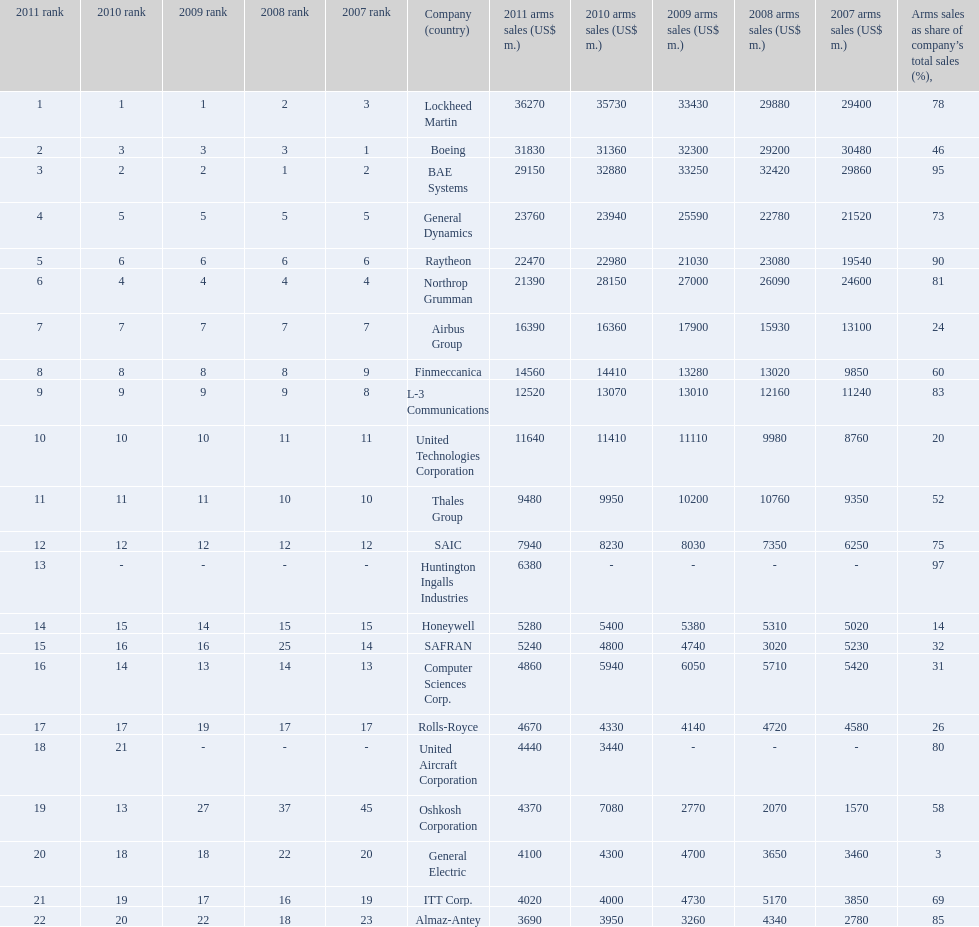Parse the full table. {'header': ['2011 rank', '2010 rank', '2009 rank', '2008 rank', '2007 rank', 'Company (country)', '2011 arms sales (US$ m.)', '2010 arms sales (US$ m.)', '2009 arms sales (US$ m.)', '2008 arms sales (US$ m.)', '2007 arms sales (US$ m.)', 'Arms sales as share of company’s total sales (%),'], 'rows': [['1', '1', '1', '2', '3', 'Lockheed Martin', '36270', '35730', '33430', '29880', '29400', '78'], ['2', '3', '3', '3', '1', 'Boeing', '31830', '31360', '32300', '29200', '30480', '46'], ['3', '2', '2', '1', '2', 'BAE Systems', '29150', '32880', '33250', '32420', '29860', '95'], ['4', '5', '5', '5', '5', 'General Dynamics', '23760', '23940', '25590', '22780', '21520', '73'], ['5', '6', '6', '6', '6', 'Raytheon', '22470', '22980', '21030', '23080', '19540', '90'], ['6', '4', '4', '4', '4', 'Northrop Grumman', '21390', '28150', '27000', '26090', '24600', '81'], ['7', '7', '7', '7', '7', 'Airbus Group', '16390', '16360', '17900', '15930', '13100', '24'], ['8', '8', '8', '8', '9', 'Finmeccanica', '14560', '14410', '13280', '13020', '9850', '60'], ['9', '9', '9', '9', '8', 'L-3 Communications', '12520', '13070', '13010', '12160', '11240', '83'], ['10', '10', '10', '11', '11', 'United Technologies Corporation', '11640', '11410', '11110', '9980', '8760', '20'], ['11', '11', '11', '10', '10', 'Thales Group', '9480', '9950', '10200', '10760', '9350', '52'], ['12', '12', '12', '12', '12', 'SAIC', '7940', '8230', '8030', '7350', '6250', '75'], ['13', '-', '-', '-', '-', 'Huntington Ingalls Industries', '6380', '-', '-', '-', '-', '97'], ['14', '15', '14', '15', '15', 'Honeywell', '5280', '5400', '5380', '5310', '5020', '14'], ['15', '16', '16', '25', '14', 'SAFRAN', '5240', '4800', '4740', '3020', '5230', '32'], ['16', '14', '13', '14', '13', 'Computer Sciences Corp.', '4860', '5940', '6050', '5710', '5420', '31'], ['17', '17', '19', '17', '17', 'Rolls-Royce', '4670', '4330', '4140', '4720', '4580', '26'], ['18', '21', '-', '-', '-', 'United Aircraft Corporation', '4440', '3440', '-', '-', '-', '80'], ['19', '13', '27', '37', '45', 'Oshkosh Corporation', '4370', '7080', '2770', '2070', '1570', '58'], ['20', '18', '18', '22', '20', 'General Electric', '4100', '4300', '4700', '3650', '3460', '3'], ['21', '19', '17', '16', '19', 'ITT Corp.', '4020', '4000', '4730', '5170', '3850', '69'], ['22', '20', '22', '18', '23', 'Almaz-Antey', '3690', '3950', '3260', '4340', '2780', '85']]} What country is the first listed country? USA. 